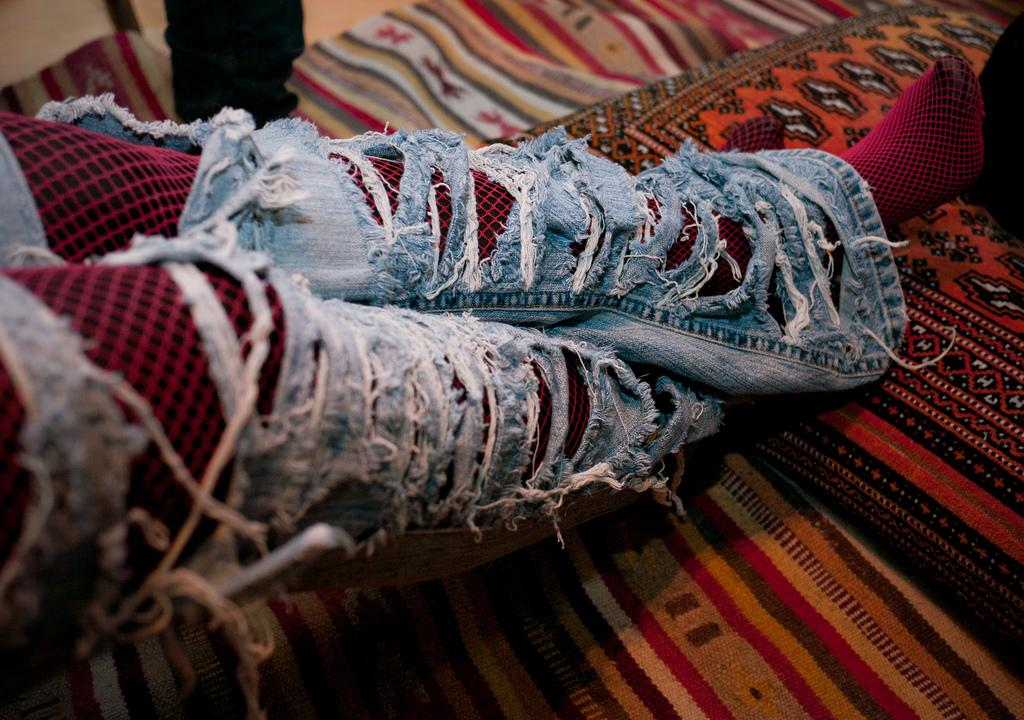What body parts can be seen in the image? Human legs are visible in the image. What type of furniture or accessory is present in the image? There is a pillow in the image. What type of flooring is visible in the image? There is a carpet in the image. How many goldfish are swimming in the image? There are no goldfish present in the image. What type of seat is visible in the image? There is no seat visible in the image. 